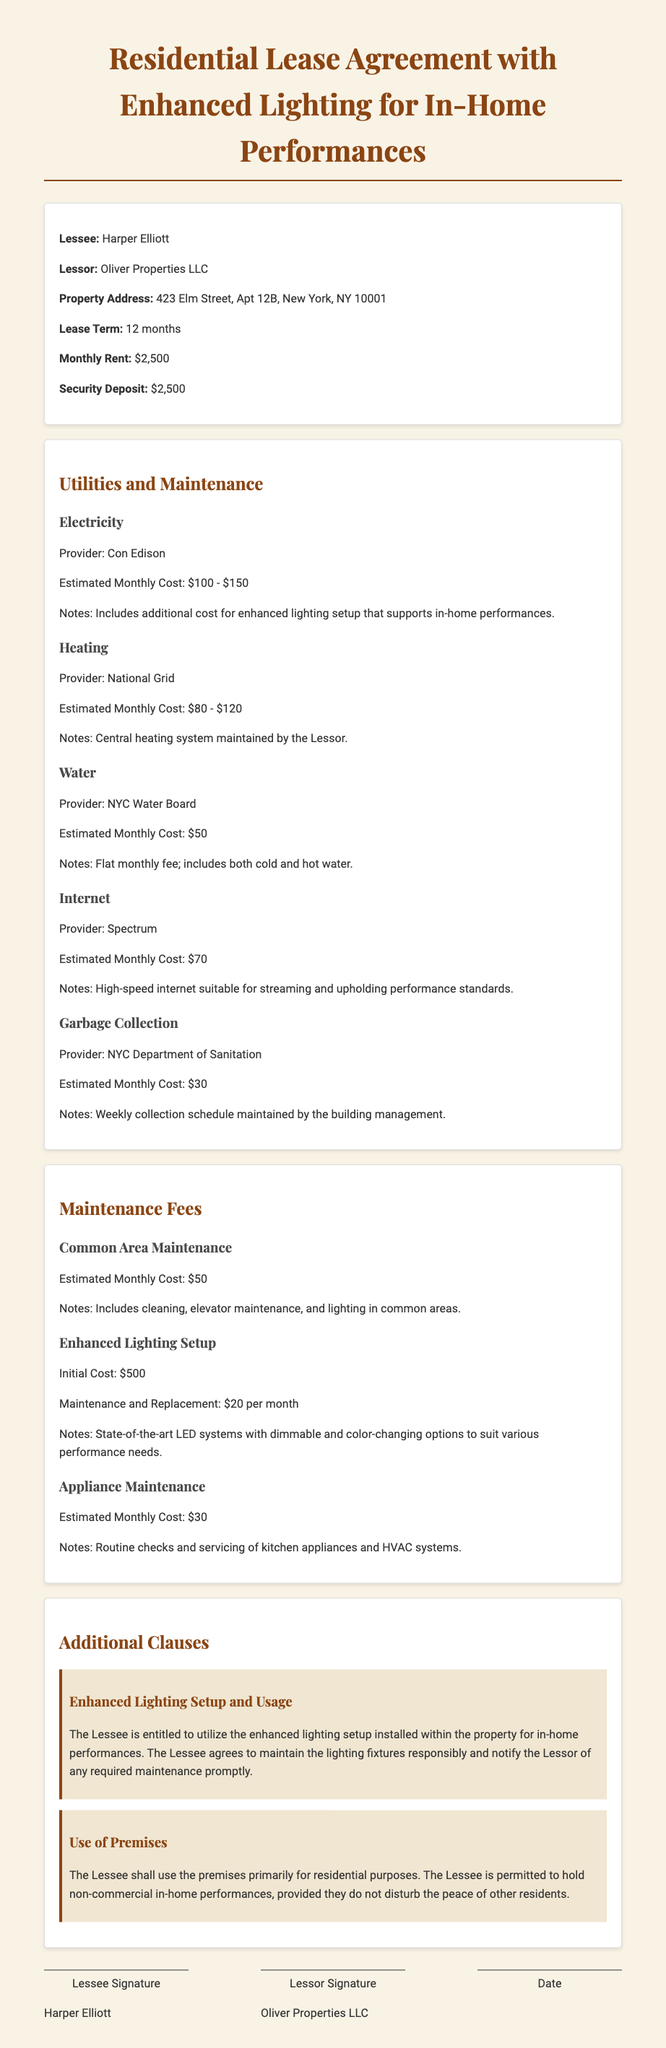What is the name of the Lessee? The name of the Lessee is clearly stated in the document under the Lessee section.
Answer: Harper Elliott What is the address of the property? The property address is specified in the initial section of the document.
Answer: 423 Elm Street, Apt 12B, New York, NY 10001 Who is the utility provider for electricity? The provider for electricity is listed in the Utilities section of the document.
Answer: Con Edison What is the estimated monthly cost for water? The estimated monthly cost for water is presented in the Utilities section.
Answer: $50 What is the initial cost for the enhanced lighting setup? The document provides the initial cost for the enhanced lighting setup in the Maintenance Fees section.
Answer: $500 How much is the maintenance fee for enhanced lighting monthly? The document details the monthly maintenance fee for enhanced lighting.
Answer: $20 What is the total estimated monthly cost for utilities excluding Internet? This requires adding the costs of electricity, heating, water, and garbage collection.
Answer: $260 - $400 Can the Lessee hold commercial performances? This question evaluates the stipulations related to the usage of the premises.
Answer: No What is the total security deposit amount? The amount for the security deposit is listed in the financial details.
Answer: $2,500 